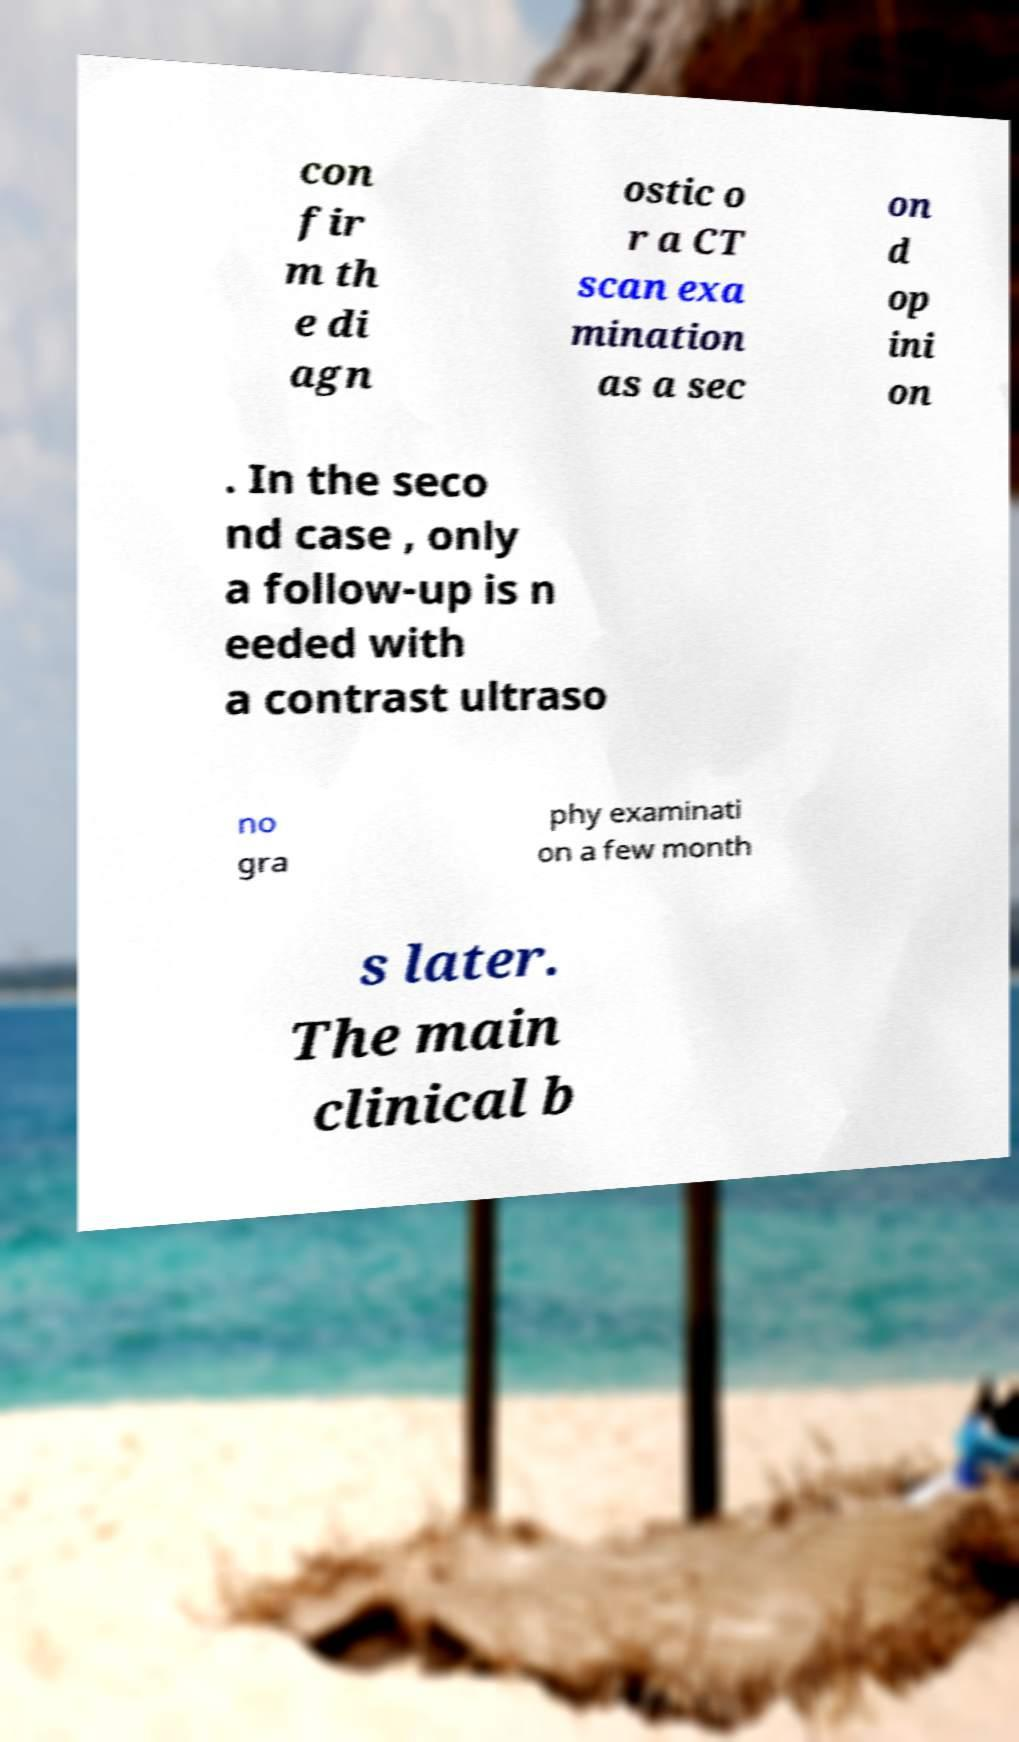I need the written content from this picture converted into text. Can you do that? con fir m th e di agn ostic o r a CT scan exa mination as a sec on d op ini on . In the seco nd case , only a follow-up is n eeded with a contrast ultraso no gra phy examinati on a few month s later. The main clinical b 